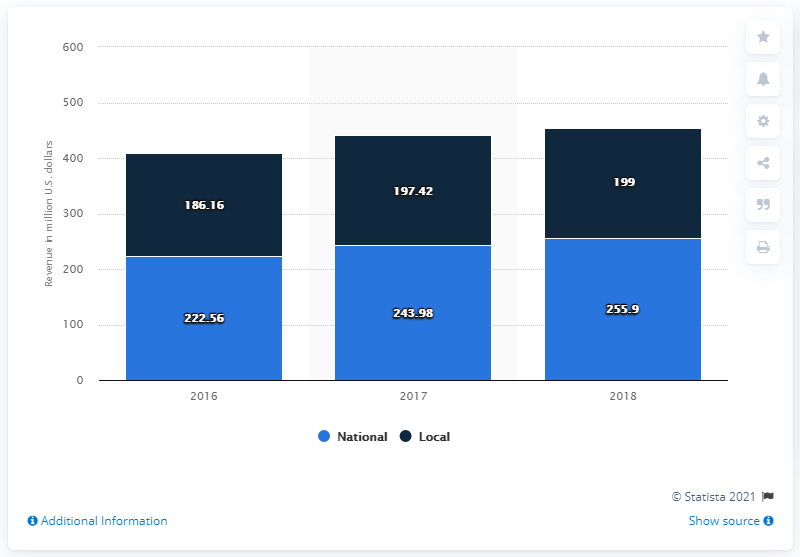Identify some key points in this picture. In 2018, the Green Bay Packers generated a national revenue of 255.9 million dollars. 